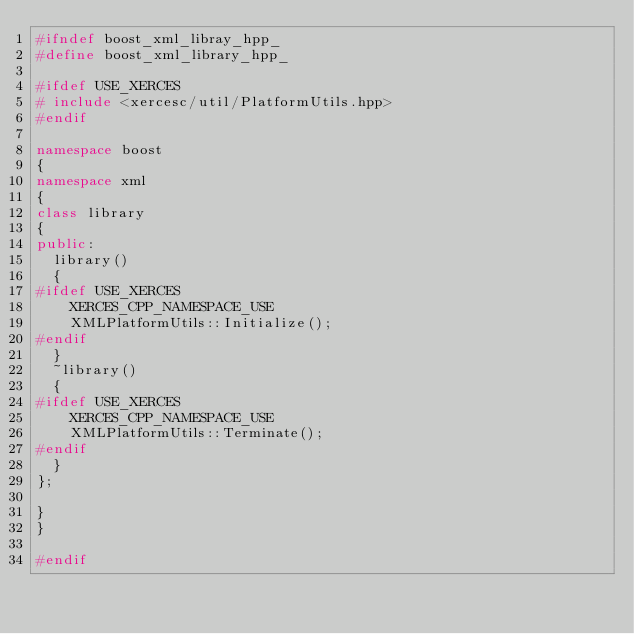<code> <loc_0><loc_0><loc_500><loc_500><_C++_>#ifndef boost_xml_libray_hpp_
#define boost_xml_library_hpp_

#ifdef USE_XERCES
# include <xercesc/util/PlatformUtils.hpp>
#endif

namespace boost
{
namespace xml
{
class library
{
public:
  library()
  {
#ifdef USE_XERCES
    XERCES_CPP_NAMESPACE_USE
    XMLPlatformUtils::Initialize();
#endif
  }
  ~library()
  {
#ifdef USE_XERCES
    XERCES_CPP_NAMESPACE_USE
    XMLPlatformUtils::Terminate();
#endif
  }
};

}
}

#endif
</code> 